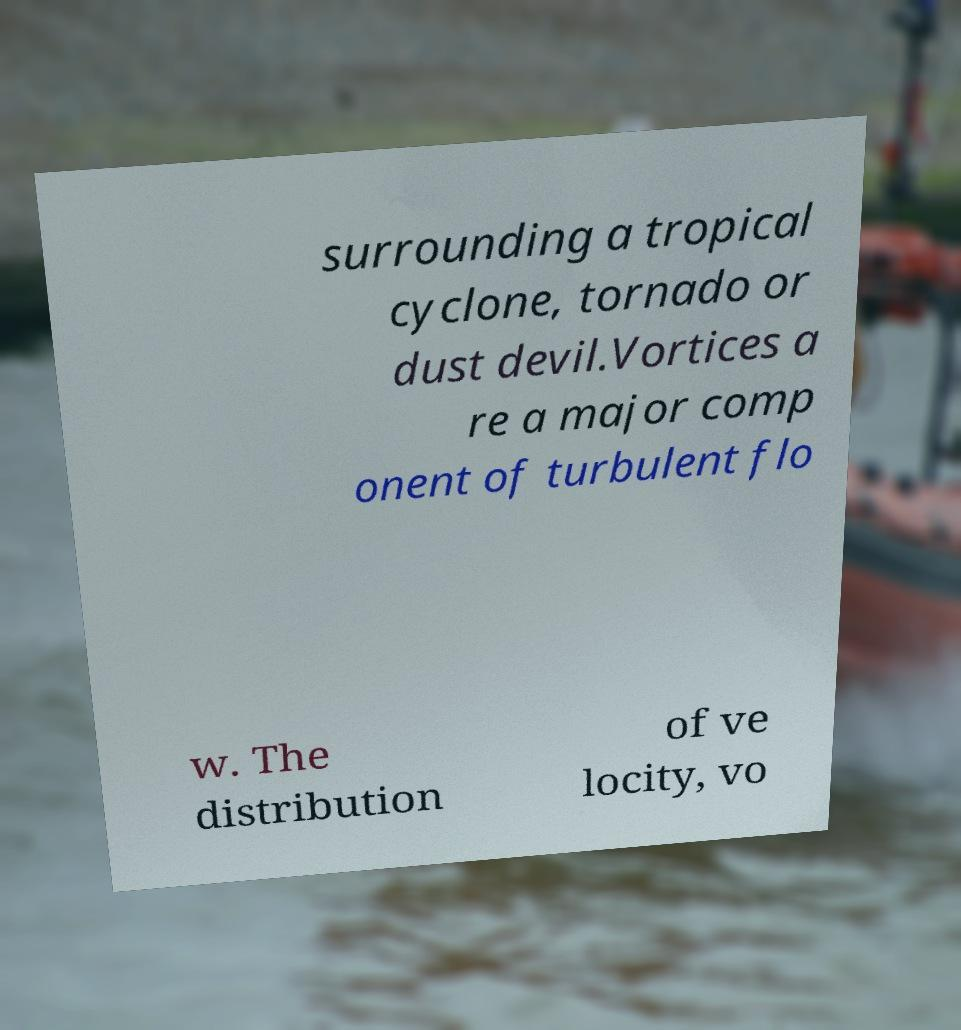There's text embedded in this image that I need extracted. Can you transcribe it verbatim? surrounding a tropical cyclone, tornado or dust devil.Vortices a re a major comp onent of turbulent flo w. The distribution of ve locity, vo 